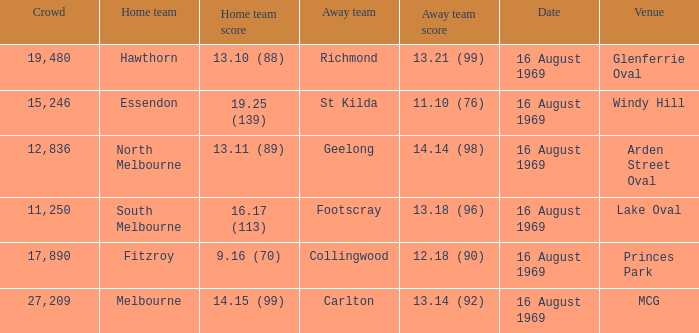When was the game played at Lake Oval? 16 August 1969. 